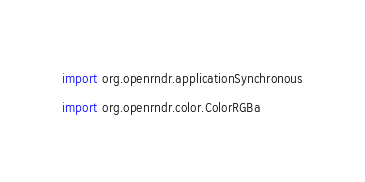Convert code to text. <code><loc_0><loc_0><loc_500><loc_500><_Kotlin_>import org.openrndr.applicationSynchronous
import org.openrndr.color.ColorRGBa</code> 